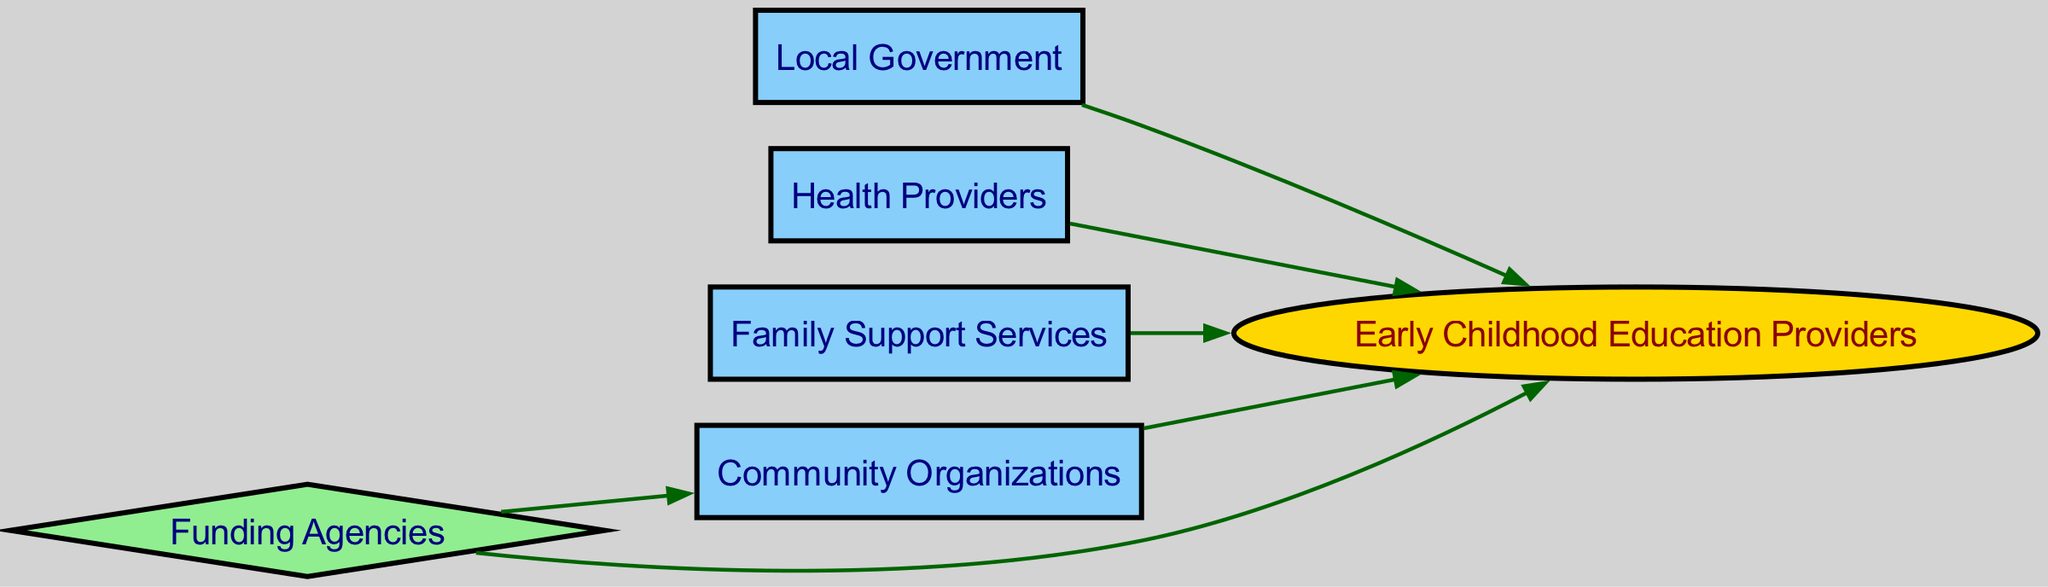What are the total number of nodes in the diagram? The diagram consists of 6 nodes: Community Organizations, Early Childhood Education Providers, Local Government, Health Providers, Family Support Services, and Funding Agencies. Counting each of these gives a total of 6 nodes.
Answer: 6 How many edges are present in the diagram? The diagram has 6 edges connecting the nodes. The edges are from Community Organizations to Early Childhood Education Providers, Local Government to Early Childhood Education Providers, Health Providers to Early Childhood Education Providers, Family Support Services to Early Childhood Education Providers, Funding Agencies to Community Organizations, and Funding Agencies to Early Childhood Education Providers. When we total these we get 6 edges.
Answer: 6 Which node has the most incoming edges? The node Early Childhood Education Providers has 4 incoming edges from Community Organizations, Local Government, Health Providers, and Family Support Services. No other node has more than 2 incoming edges. Therefore, the answer is the Early Childhood Education Providers.
Answer: Early Childhood Education Providers What is the relationship between Community Organizations and Early Childhood Education Providers? Community Organizations has a direct edge pointing to Early Childhood Education Providers, indicating a partnership that indicates support or collaboration between them.
Answer: Collaboration Which node is a funding source for other entities? Funding Agencies serves as a source of funding that connects to both Community Organizations and Early Childhood Education Providers, suggesting that it provides financial resources for these entities.
Answer: Funding Agencies How does the Local Government contribute to early childhood education services? The Local Government has a direct edge pointing to Early Childhood Education Providers, indicating its role in providing support or oversight to enhance early childhood education services. This relationship signifies governmental involvement.
Answer: Support Are Family Support Services directly connected to Funding Agencies? There is no direct edge connecting Family Support Services to Funding Agencies in the diagram, which means they do not have a direct relationship. Therefore, the answer is no.
Answer: No What type of node is Early Childhood Education Providers? In the diagram, the Early Childhood Education Providers are represented as an ellipse shape, which signifies its unique role compared to other nodes. This type of node indicates the central aspect of early childhood education services.
Answer: Ellipse What is the nature of the relationship between Health Providers and Early Childhood Education Providers? The edge from Health Providers to Early Childhood Education Providers suggests a partnership that likely relates to health services, aiding in the overall effectiveness of early childhood education by addressing health needs.
Answer: Partnership 